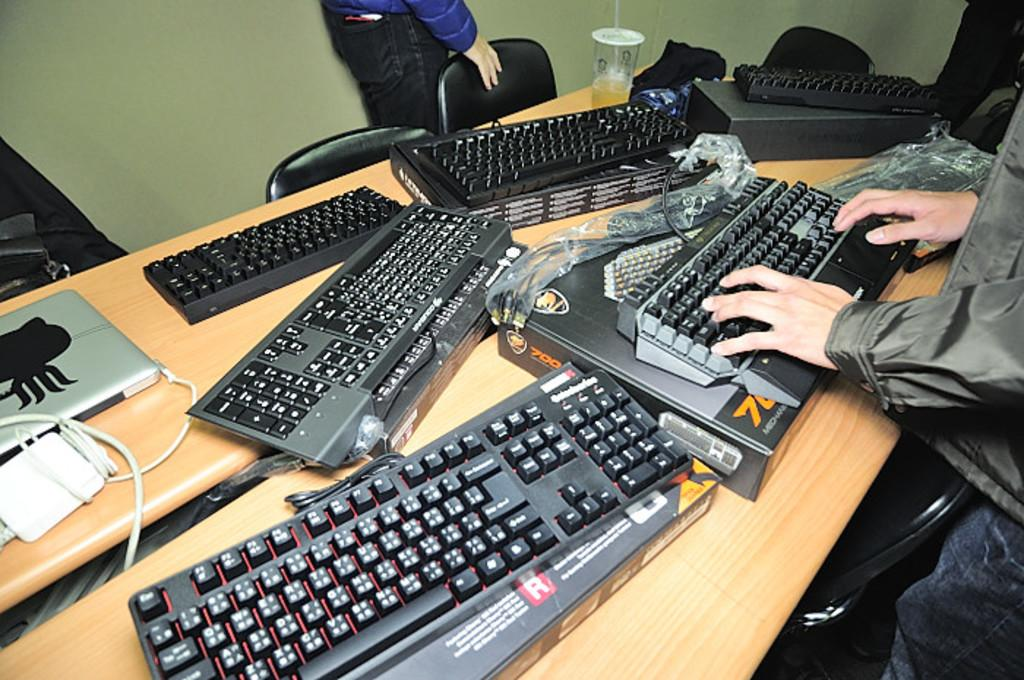Provide a one-sentence caption for the provided image. A man's hands are showing using the keyboard on the box labeled "700" and something, but it's obscured. 